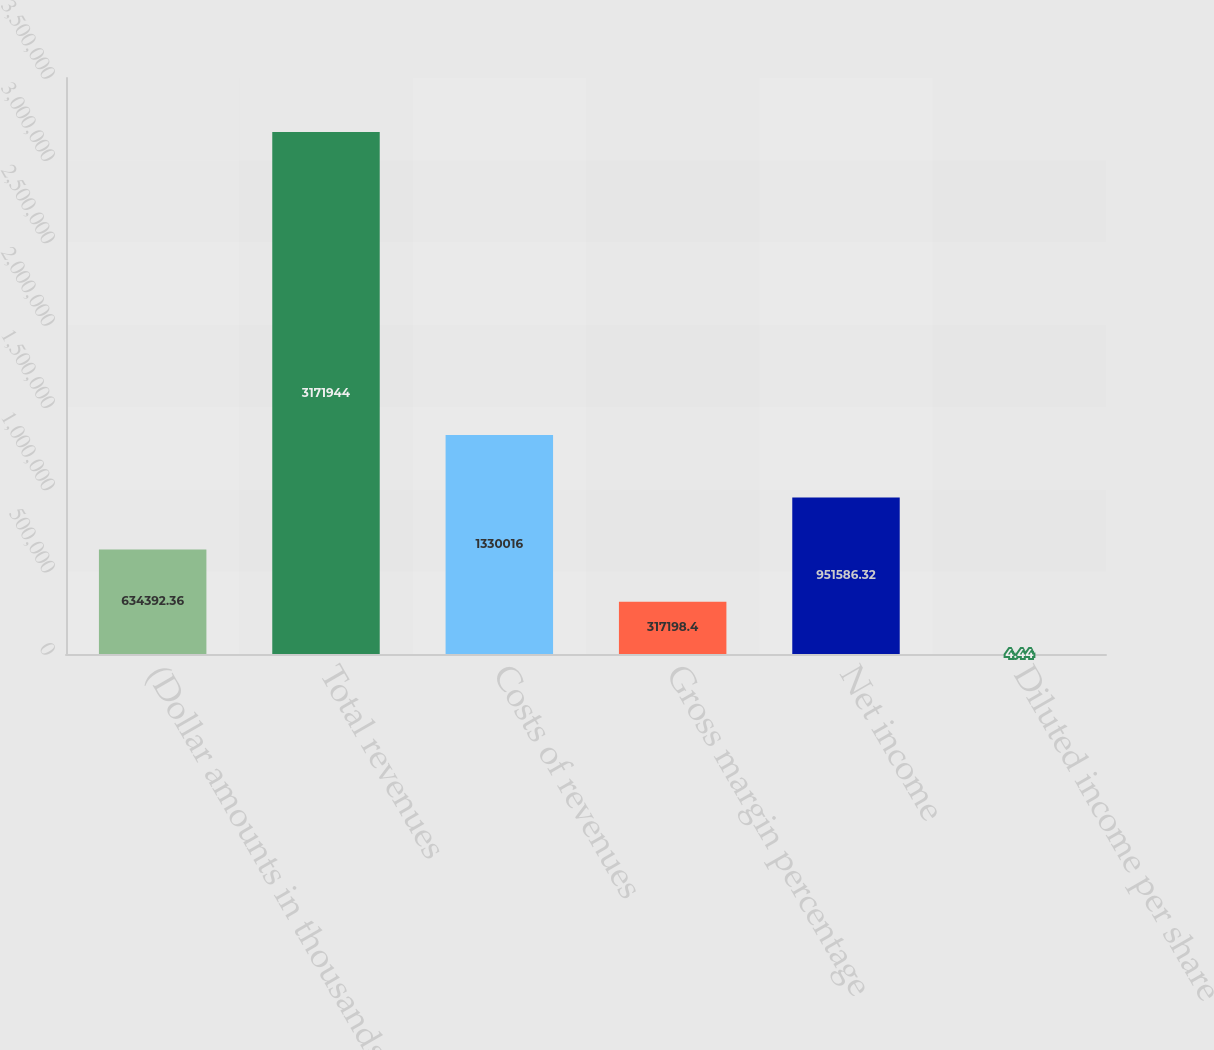Convert chart to OTSL. <chart><loc_0><loc_0><loc_500><loc_500><bar_chart><fcel>(Dollar amounts in thousands)<fcel>Total revenues<fcel>Costs of revenues<fcel>Gross margin percentage<fcel>Net income<fcel>Diluted income per share<nl><fcel>634392<fcel>3.17194e+06<fcel>1.33002e+06<fcel>317198<fcel>951586<fcel>4.44<nl></chart> 